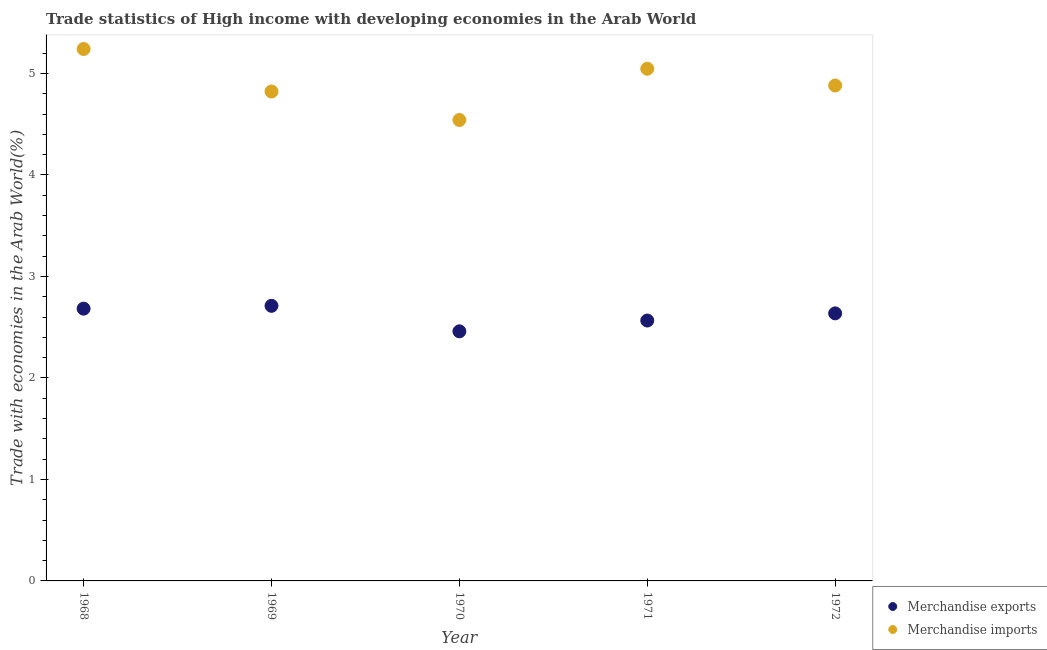How many different coloured dotlines are there?
Offer a very short reply. 2. Is the number of dotlines equal to the number of legend labels?
Ensure brevity in your answer.  Yes. What is the merchandise exports in 1969?
Give a very brief answer. 2.71. Across all years, what is the maximum merchandise imports?
Keep it short and to the point. 5.24. Across all years, what is the minimum merchandise exports?
Provide a short and direct response. 2.46. In which year was the merchandise imports maximum?
Your response must be concise. 1968. In which year was the merchandise exports minimum?
Ensure brevity in your answer.  1970. What is the total merchandise exports in the graph?
Keep it short and to the point. 13.06. What is the difference between the merchandise imports in 1970 and that in 1971?
Provide a succinct answer. -0.5. What is the difference between the merchandise exports in 1972 and the merchandise imports in 1970?
Ensure brevity in your answer.  -1.91. What is the average merchandise exports per year?
Your response must be concise. 2.61. In the year 1972, what is the difference between the merchandise imports and merchandise exports?
Your response must be concise. 2.25. What is the ratio of the merchandise exports in 1970 to that in 1971?
Your answer should be very brief. 0.96. Is the merchandise imports in 1970 less than that in 1971?
Your response must be concise. Yes. Is the difference between the merchandise exports in 1971 and 1972 greater than the difference between the merchandise imports in 1971 and 1972?
Keep it short and to the point. No. What is the difference between the highest and the second highest merchandise exports?
Your answer should be compact. 0.03. What is the difference between the highest and the lowest merchandise imports?
Provide a succinct answer. 0.7. Is the sum of the merchandise exports in 1970 and 1972 greater than the maximum merchandise imports across all years?
Your response must be concise. No. Does the merchandise imports monotonically increase over the years?
Provide a succinct answer. No. Is the merchandise exports strictly greater than the merchandise imports over the years?
Your answer should be compact. No. Is the merchandise imports strictly less than the merchandise exports over the years?
Ensure brevity in your answer.  No. How many years are there in the graph?
Your response must be concise. 5. What is the difference between two consecutive major ticks on the Y-axis?
Make the answer very short. 1. Are the values on the major ticks of Y-axis written in scientific E-notation?
Provide a short and direct response. No. Does the graph contain any zero values?
Provide a short and direct response. No. Does the graph contain grids?
Offer a terse response. No. How are the legend labels stacked?
Your response must be concise. Vertical. What is the title of the graph?
Your response must be concise. Trade statistics of High income with developing economies in the Arab World. Does "Research and Development" appear as one of the legend labels in the graph?
Ensure brevity in your answer.  No. What is the label or title of the Y-axis?
Ensure brevity in your answer.  Trade with economies in the Arab World(%). What is the Trade with economies in the Arab World(%) of Merchandise exports in 1968?
Offer a very short reply. 2.68. What is the Trade with economies in the Arab World(%) in Merchandise imports in 1968?
Your answer should be very brief. 5.24. What is the Trade with economies in the Arab World(%) of Merchandise exports in 1969?
Keep it short and to the point. 2.71. What is the Trade with economies in the Arab World(%) in Merchandise imports in 1969?
Make the answer very short. 4.82. What is the Trade with economies in the Arab World(%) of Merchandise exports in 1970?
Provide a short and direct response. 2.46. What is the Trade with economies in the Arab World(%) in Merchandise imports in 1970?
Your response must be concise. 4.54. What is the Trade with economies in the Arab World(%) of Merchandise exports in 1971?
Offer a terse response. 2.57. What is the Trade with economies in the Arab World(%) in Merchandise imports in 1971?
Give a very brief answer. 5.05. What is the Trade with economies in the Arab World(%) of Merchandise exports in 1972?
Provide a succinct answer. 2.64. What is the Trade with economies in the Arab World(%) of Merchandise imports in 1972?
Offer a very short reply. 4.88. Across all years, what is the maximum Trade with economies in the Arab World(%) in Merchandise exports?
Make the answer very short. 2.71. Across all years, what is the maximum Trade with economies in the Arab World(%) of Merchandise imports?
Your answer should be very brief. 5.24. Across all years, what is the minimum Trade with economies in the Arab World(%) in Merchandise exports?
Keep it short and to the point. 2.46. Across all years, what is the minimum Trade with economies in the Arab World(%) in Merchandise imports?
Offer a terse response. 4.54. What is the total Trade with economies in the Arab World(%) of Merchandise exports in the graph?
Make the answer very short. 13.06. What is the total Trade with economies in the Arab World(%) of Merchandise imports in the graph?
Offer a very short reply. 24.53. What is the difference between the Trade with economies in the Arab World(%) in Merchandise exports in 1968 and that in 1969?
Your answer should be very brief. -0.03. What is the difference between the Trade with economies in the Arab World(%) in Merchandise imports in 1968 and that in 1969?
Provide a short and direct response. 0.42. What is the difference between the Trade with economies in the Arab World(%) in Merchandise exports in 1968 and that in 1970?
Make the answer very short. 0.22. What is the difference between the Trade with economies in the Arab World(%) of Merchandise imports in 1968 and that in 1970?
Your answer should be very brief. 0.7. What is the difference between the Trade with economies in the Arab World(%) of Merchandise exports in 1968 and that in 1971?
Your answer should be very brief. 0.12. What is the difference between the Trade with economies in the Arab World(%) in Merchandise imports in 1968 and that in 1971?
Ensure brevity in your answer.  0.19. What is the difference between the Trade with economies in the Arab World(%) of Merchandise exports in 1968 and that in 1972?
Your response must be concise. 0.05. What is the difference between the Trade with economies in the Arab World(%) of Merchandise imports in 1968 and that in 1972?
Your response must be concise. 0.36. What is the difference between the Trade with economies in the Arab World(%) of Merchandise exports in 1969 and that in 1970?
Offer a terse response. 0.25. What is the difference between the Trade with economies in the Arab World(%) of Merchandise imports in 1969 and that in 1970?
Your answer should be compact. 0.28. What is the difference between the Trade with economies in the Arab World(%) in Merchandise exports in 1969 and that in 1971?
Your answer should be compact. 0.14. What is the difference between the Trade with economies in the Arab World(%) of Merchandise imports in 1969 and that in 1971?
Offer a very short reply. -0.22. What is the difference between the Trade with economies in the Arab World(%) of Merchandise exports in 1969 and that in 1972?
Your response must be concise. 0.07. What is the difference between the Trade with economies in the Arab World(%) in Merchandise imports in 1969 and that in 1972?
Make the answer very short. -0.06. What is the difference between the Trade with economies in the Arab World(%) of Merchandise exports in 1970 and that in 1971?
Make the answer very short. -0.11. What is the difference between the Trade with economies in the Arab World(%) of Merchandise imports in 1970 and that in 1971?
Keep it short and to the point. -0.5. What is the difference between the Trade with economies in the Arab World(%) of Merchandise exports in 1970 and that in 1972?
Keep it short and to the point. -0.18. What is the difference between the Trade with economies in the Arab World(%) of Merchandise imports in 1970 and that in 1972?
Offer a very short reply. -0.34. What is the difference between the Trade with economies in the Arab World(%) of Merchandise exports in 1971 and that in 1972?
Make the answer very short. -0.07. What is the difference between the Trade with economies in the Arab World(%) of Merchandise imports in 1971 and that in 1972?
Your answer should be very brief. 0.17. What is the difference between the Trade with economies in the Arab World(%) of Merchandise exports in 1968 and the Trade with economies in the Arab World(%) of Merchandise imports in 1969?
Provide a succinct answer. -2.14. What is the difference between the Trade with economies in the Arab World(%) in Merchandise exports in 1968 and the Trade with economies in the Arab World(%) in Merchandise imports in 1970?
Your answer should be very brief. -1.86. What is the difference between the Trade with economies in the Arab World(%) of Merchandise exports in 1968 and the Trade with economies in the Arab World(%) of Merchandise imports in 1971?
Give a very brief answer. -2.36. What is the difference between the Trade with economies in the Arab World(%) of Merchandise exports in 1968 and the Trade with economies in the Arab World(%) of Merchandise imports in 1972?
Offer a very short reply. -2.2. What is the difference between the Trade with economies in the Arab World(%) in Merchandise exports in 1969 and the Trade with economies in the Arab World(%) in Merchandise imports in 1970?
Your answer should be compact. -1.83. What is the difference between the Trade with economies in the Arab World(%) in Merchandise exports in 1969 and the Trade with economies in the Arab World(%) in Merchandise imports in 1971?
Provide a succinct answer. -2.34. What is the difference between the Trade with economies in the Arab World(%) in Merchandise exports in 1969 and the Trade with economies in the Arab World(%) in Merchandise imports in 1972?
Offer a terse response. -2.17. What is the difference between the Trade with economies in the Arab World(%) in Merchandise exports in 1970 and the Trade with economies in the Arab World(%) in Merchandise imports in 1971?
Your response must be concise. -2.59. What is the difference between the Trade with economies in the Arab World(%) in Merchandise exports in 1970 and the Trade with economies in the Arab World(%) in Merchandise imports in 1972?
Keep it short and to the point. -2.42. What is the difference between the Trade with economies in the Arab World(%) of Merchandise exports in 1971 and the Trade with economies in the Arab World(%) of Merchandise imports in 1972?
Your answer should be compact. -2.32. What is the average Trade with economies in the Arab World(%) of Merchandise exports per year?
Keep it short and to the point. 2.61. What is the average Trade with economies in the Arab World(%) of Merchandise imports per year?
Make the answer very short. 4.91. In the year 1968, what is the difference between the Trade with economies in the Arab World(%) in Merchandise exports and Trade with economies in the Arab World(%) in Merchandise imports?
Your response must be concise. -2.56. In the year 1969, what is the difference between the Trade with economies in the Arab World(%) of Merchandise exports and Trade with economies in the Arab World(%) of Merchandise imports?
Your answer should be compact. -2.11. In the year 1970, what is the difference between the Trade with economies in the Arab World(%) of Merchandise exports and Trade with economies in the Arab World(%) of Merchandise imports?
Provide a succinct answer. -2.08. In the year 1971, what is the difference between the Trade with economies in the Arab World(%) of Merchandise exports and Trade with economies in the Arab World(%) of Merchandise imports?
Give a very brief answer. -2.48. In the year 1972, what is the difference between the Trade with economies in the Arab World(%) in Merchandise exports and Trade with economies in the Arab World(%) in Merchandise imports?
Offer a terse response. -2.25. What is the ratio of the Trade with economies in the Arab World(%) of Merchandise exports in 1968 to that in 1969?
Provide a short and direct response. 0.99. What is the ratio of the Trade with economies in the Arab World(%) of Merchandise imports in 1968 to that in 1969?
Provide a short and direct response. 1.09. What is the ratio of the Trade with economies in the Arab World(%) in Merchandise exports in 1968 to that in 1970?
Ensure brevity in your answer.  1.09. What is the ratio of the Trade with economies in the Arab World(%) in Merchandise imports in 1968 to that in 1970?
Provide a succinct answer. 1.15. What is the ratio of the Trade with economies in the Arab World(%) in Merchandise exports in 1968 to that in 1971?
Ensure brevity in your answer.  1.05. What is the ratio of the Trade with economies in the Arab World(%) in Merchandise imports in 1968 to that in 1971?
Offer a terse response. 1.04. What is the ratio of the Trade with economies in the Arab World(%) in Merchandise exports in 1968 to that in 1972?
Your answer should be very brief. 1.02. What is the ratio of the Trade with economies in the Arab World(%) in Merchandise imports in 1968 to that in 1972?
Offer a terse response. 1.07. What is the ratio of the Trade with economies in the Arab World(%) of Merchandise exports in 1969 to that in 1970?
Give a very brief answer. 1.1. What is the ratio of the Trade with economies in the Arab World(%) in Merchandise imports in 1969 to that in 1970?
Offer a very short reply. 1.06. What is the ratio of the Trade with economies in the Arab World(%) in Merchandise exports in 1969 to that in 1971?
Your answer should be compact. 1.06. What is the ratio of the Trade with economies in the Arab World(%) of Merchandise imports in 1969 to that in 1971?
Offer a terse response. 0.96. What is the ratio of the Trade with economies in the Arab World(%) in Merchandise exports in 1969 to that in 1972?
Give a very brief answer. 1.03. What is the ratio of the Trade with economies in the Arab World(%) of Merchandise imports in 1969 to that in 1972?
Provide a short and direct response. 0.99. What is the ratio of the Trade with economies in the Arab World(%) of Merchandise exports in 1970 to that in 1971?
Your answer should be compact. 0.96. What is the ratio of the Trade with economies in the Arab World(%) in Merchandise exports in 1970 to that in 1972?
Make the answer very short. 0.93. What is the ratio of the Trade with economies in the Arab World(%) in Merchandise imports in 1970 to that in 1972?
Keep it short and to the point. 0.93. What is the ratio of the Trade with economies in the Arab World(%) in Merchandise exports in 1971 to that in 1972?
Make the answer very short. 0.97. What is the ratio of the Trade with economies in the Arab World(%) in Merchandise imports in 1971 to that in 1972?
Your answer should be compact. 1.03. What is the difference between the highest and the second highest Trade with economies in the Arab World(%) in Merchandise exports?
Your answer should be compact. 0.03. What is the difference between the highest and the second highest Trade with economies in the Arab World(%) in Merchandise imports?
Give a very brief answer. 0.19. What is the difference between the highest and the lowest Trade with economies in the Arab World(%) in Merchandise exports?
Give a very brief answer. 0.25. What is the difference between the highest and the lowest Trade with economies in the Arab World(%) in Merchandise imports?
Provide a short and direct response. 0.7. 